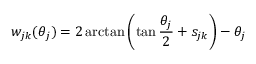Convert formula to latex. <formula><loc_0><loc_0><loc_500><loc_500>w _ { j k } ( \theta _ { j } ) = 2 \arctan \left ( \tan \frac { \theta _ { j } } 2 + s _ { j k } \right ) - \theta _ { j }</formula> 